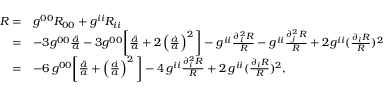Convert formula to latex. <formula><loc_0><loc_0><loc_500><loc_500>\begin{array} { r l } { R = } & { g ^ { 0 0 } R _ { 0 0 } + g ^ { i i } R _ { i i } } \\ { = } & { - 3 g ^ { 0 0 } \frac { \ddot { a } } { a } - 3 g ^ { 0 0 } \left [ \frac { \ddot { a } } { a } + 2 \left ( \frac { \dot { a } } { a } \right ) ^ { 2 } \right ] - g ^ { i i } \frac { \partial _ { i } ^ { 2 } R } { R } - g ^ { i i } \frac { \partial _ { j } ^ { 2 } R } { R } + 2 g ^ { i i } ( \frac { \partial _ { i } R } { R } ) ^ { 2 } } \\ { = } & { - 6 \, g ^ { 0 0 } \left [ \frac { \ddot { a } } { a } + \left ( \frac { \dot { a } } { a } \right ) ^ { 2 } \right ] - 4 \, g ^ { i i } \frac { \partial _ { i } ^ { 2 } R } { R } + 2 \, g ^ { i i } ( \frac { \partial _ { i } R } { R } ) ^ { 2 } , } \end{array}</formula> 